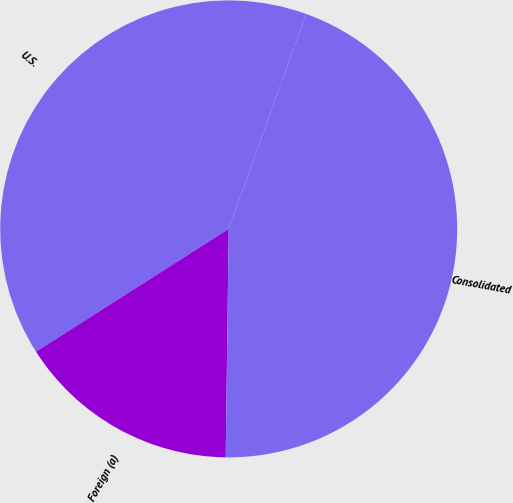Convert chart. <chart><loc_0><loc_0><loc_500><loc_500><pie_chart><fcel>U.S.<fcel>Foreign (a)<fcel>Consolidated<nl><fcel>39.53%<fcel>15.76%<fcel>44.71%<nl></chart> 